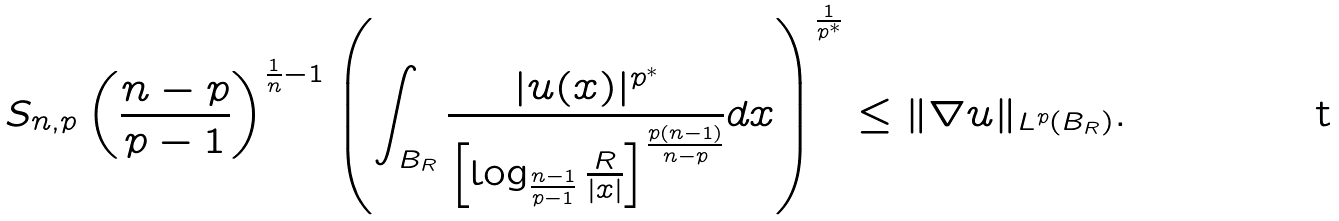Convert formula to latex. <formula><loc_0><loc_0><loc_500><loc_500>S _ { n , p } \left ( \frac { n - p } { p - 1 } \right ) ^ { \frac { 1 } { n } - 1 } \left ( \int _ { B _ { R } } \frac { | u ( x ) | ^ { p ^ { * } } } { \left [ \log _ { { \frac { n - 1 } { p - 1 } } } \frac { R } { | x | } \right ] ^ { \frac { p ( n - 1 ) } { n - p } } } d x \right ) ^ { \frac { 1 } { p ^ { * } } } \leq \| \nabla u \| _ { L ^ { p } ( B _ { R } ) } .</formula> 